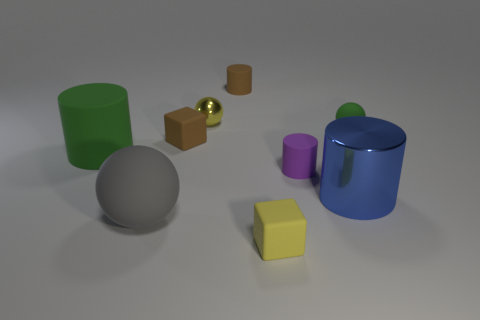Subtract 1 cylinders. How many cylinders are left? 3 Add 1 large blue cylinders. How many objects exist? 10 Subtract all cylinders. How many objects are left? 5 Subtract all tiny blue matte spheres. Subtract all gray objects. How many objects are left? 8 Add 3 purple rubber things. How many purple rubber things are left? 4 Add 7 small metallic spheres. How many small metallic spheres exist? 8 Subtract 0 blue blocks. How many objects are left? 9 